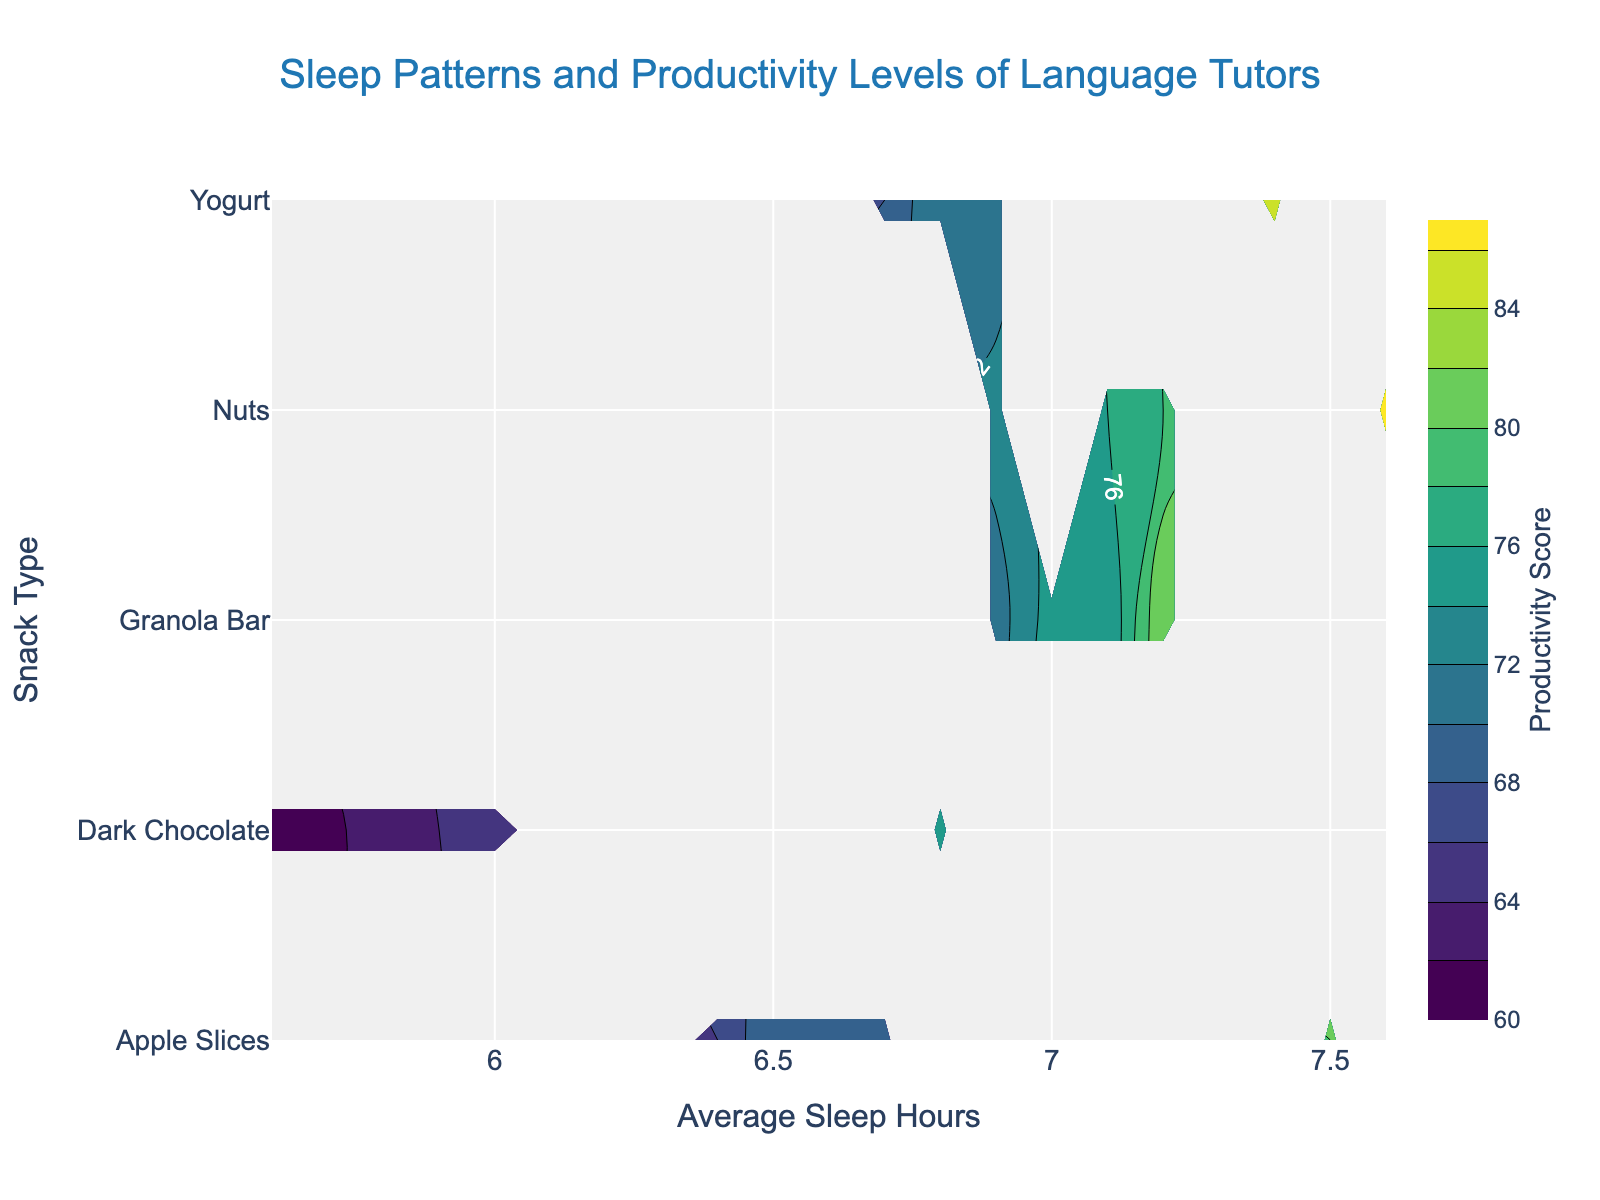What's the title of the figure? The title is usually located at the top center part of the figure. From the visual inspection, it reads "Sleep Patterns and Productivity Levels of Language Tutors."
Answer: Sleep Patterns and Productivity Levels of Language Tutors What is the x-axis title in the figure? The x-axis title is usually found beneath the x-axis, which displays the horizontal variable. In this figure, it reads "Average Sleep Hours."
Answer: Average Sleep Hours What is the y-axis title in the figure? The y-axis title is usually located next to the y-axis, which displays the vertical variable. In this figure, it reads "Snack Type."
Answer: Snack Type Which snack type shows the highest productivity score for average sleep hours above 7? In the contour plot, the highest productivity score is indicated by the brightest color. For average sleep hours above 7, the "Nuts" snack type reaches the highest score.
Answer: Nuts Which time of the day shows the overall highest productivity score, considering the contour plot? The area with the overall brightest color indicates the highest productivity. The contour plot shows the highest productivity scores in the "After_lesson" category.
Answer: After_lesson Compare the productivity scores for "Yogurt" and "Dark Chocolate" snacks for average sleep hours of 6.5. Which one is higher? Look at the contour lines for 6.5 hours of sleep and compare the brightness levels for "Yogurt" and "Dark Chocolate". "Yogurt" has a higher productivity score.
Answer: Yogurt What is the approximate range of productivity scores for "Granola Bar" with average sleep hours between 6 and 7 hours? Find the section corresponding to "Granola Bar" and note the contour levels between 6 and 7 hours. The productivity scores range approximately from 71 to 75.
Answer: 71 to 75 How do productivity scores for "Apple Slices" compare between morning and after lesson times? Compare the color intensity of the contours for "Apple Slices" between morning and after lesson times. "Apple Slices" shows higher productivity scores in the after lesson times.
Answer: Higher after lessons What's the lowest productivity score observed in the figure and which snack and sleep-hours combination does it belong to? The contour plot's darkest color shows the lowest productivity score. The combination of "Dark Chocolate" with sleep hours around 5.6 represents the lowest score.
Answer: Dark Chocolate, 5.6 hours 